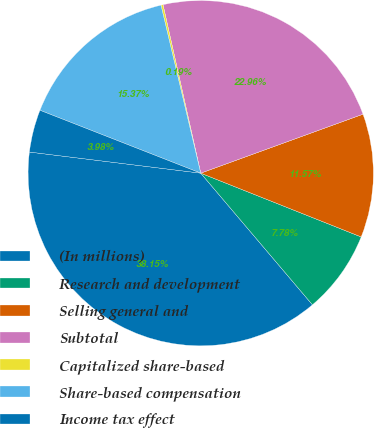Convert chart. <chart><loc_0><loc_0><loc_500><loc_500><pie_chart><fcel>(In millions)<fcel>Research and development<fcel>Selling general and<fcel>Subtotal<fcel>Capitalized share-based<fcel>Share-based compensation<fcel>Income tax effect<nl><fcel>38.15%<fcel>7.78%<fcel>11.57%<fcel>22.96%<fcel>0.19%<fcel>15.37%<fcel>3.98%<nl></chart> 